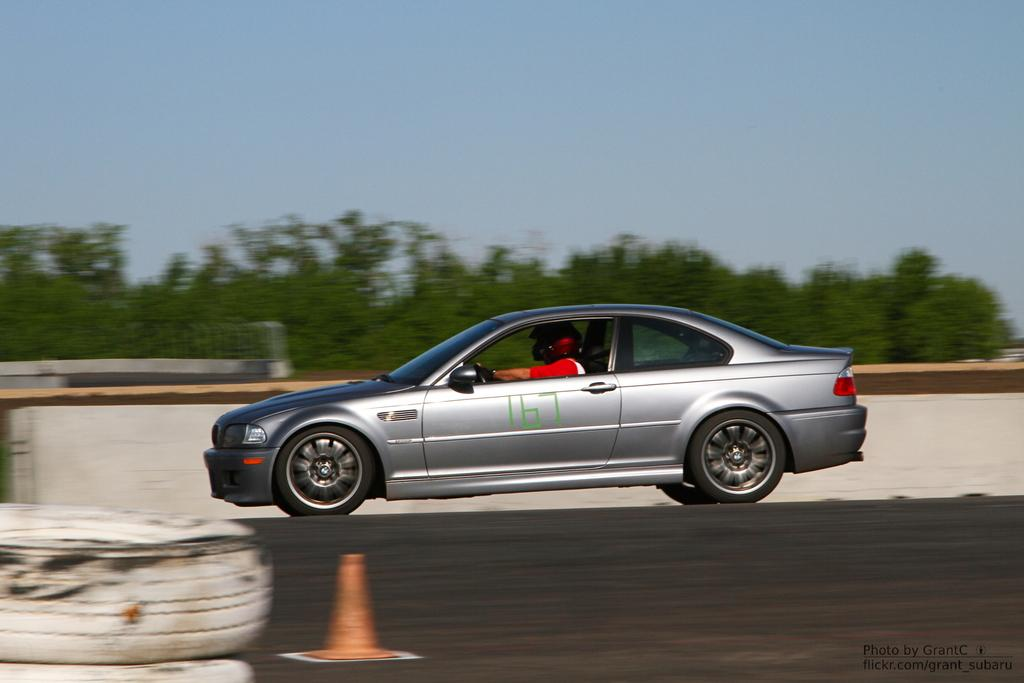What is the person in the image doing? There is a person riding a car in the image. Where is the car located? The car is on the road. What object can be seen near the car? There is a traffic cone in the image. What can be seen on the car? There are tyres on the car. What is visible in the background of the image? There is a wall, trees, and the sky visible in the background of the image. What type of nut can be heard cracking in the image? There is no nut present in the image, and therefore no sound of cracking can be heard. 